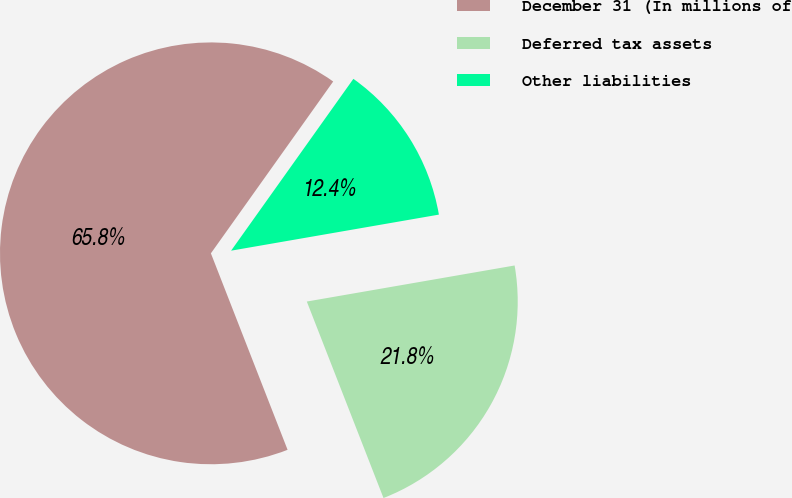Convert chart. <chart><loc_0><loc_0><loc_500><loc_500><pie_chart><fcel>December 31 (In millions of<fcel>Deferred tax assets<fcel>Other liabilities<nl><fcel>65.76%<fcel>21.81%<fcel>12.42%<nl></chart> 